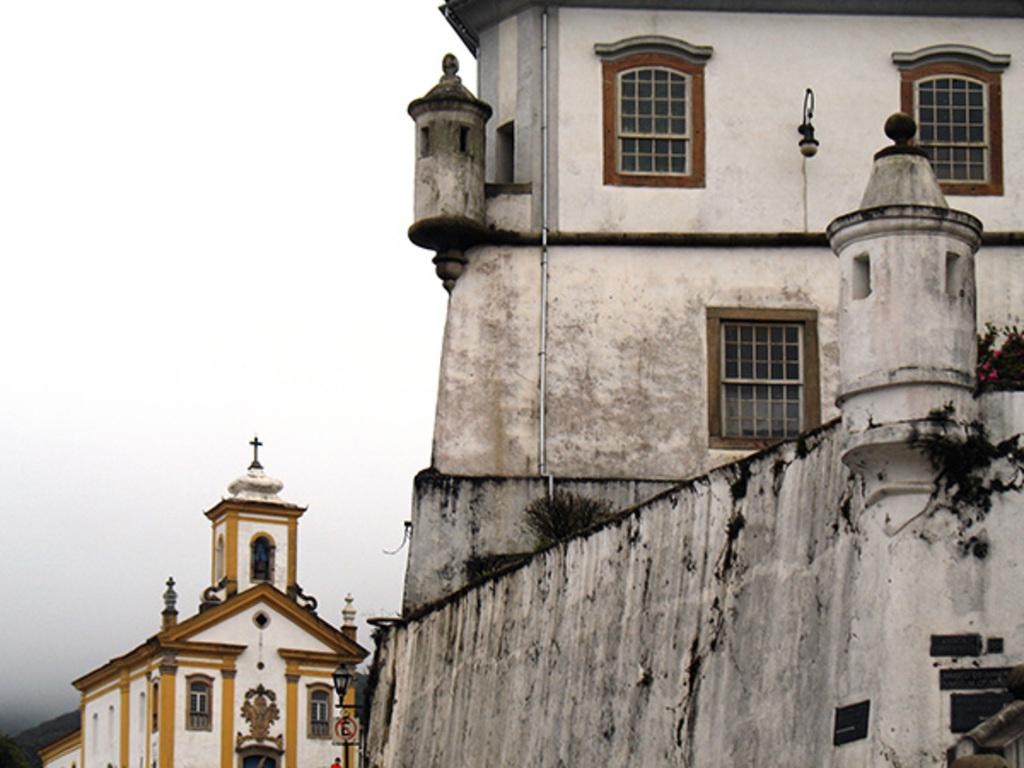How many buildings can be seen in the image? There are two buildings in the image. Can you describe the appearance of the new building? The new building is white in color. How does the other building compare to the new one? The other building is old. What type of potato is being used to expand the old building in the image? There is no potato or expansion activity present in the image. 